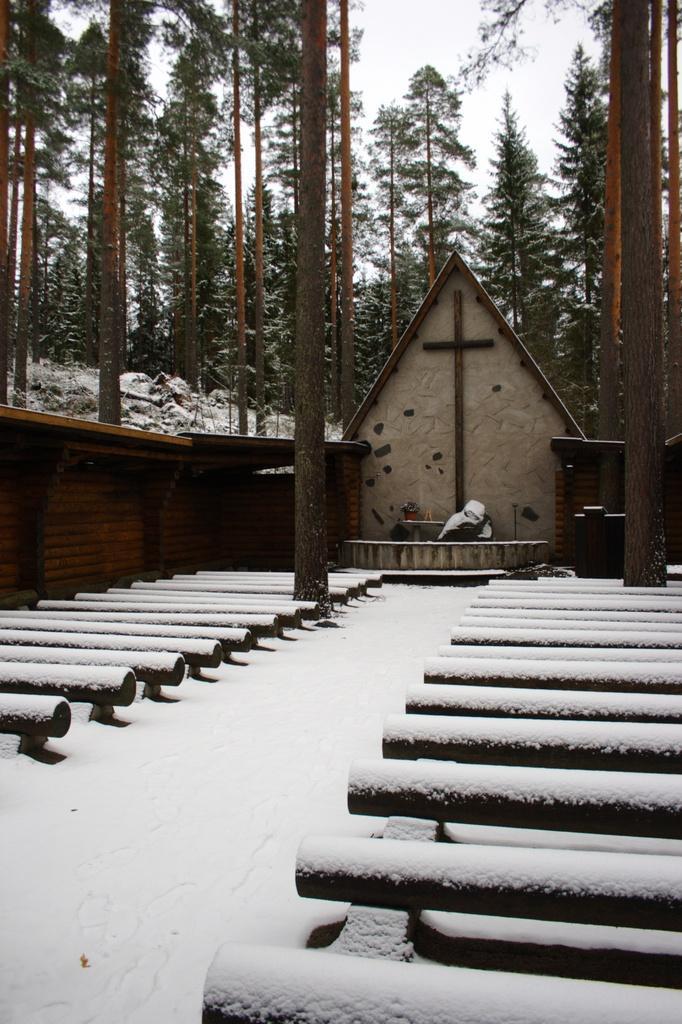In one or two sentences, can you explain what this image depicts? In this image in the center there is one house and some benches, poles and in the background there are some trees. At the bottom there is snow and in the center there is one cross. 